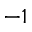<formula> <loc_0><loc_0><loc_500><loc_500>^ { - 1 }</formula> 